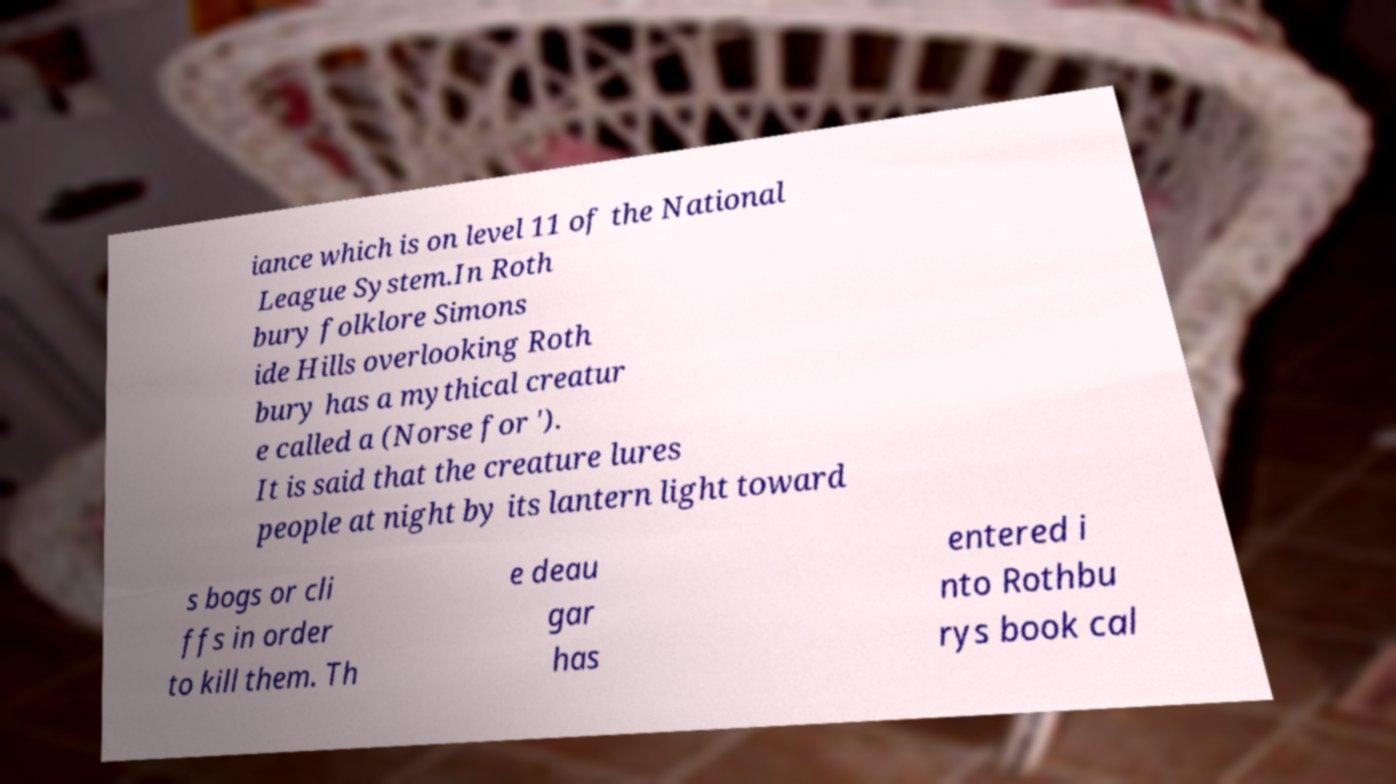What messages or text are displayed in this image? I need them in a readable, typed format. iance which is on level 11 of the National League System.In Roth bury folklore Simons ide Hills overlooking Roth bury has a mythical creatur e called a (Norse for '). It is said that the creature lures people at night by its lantern light toward s bogs or cli ffs in order to kill them. Th e deau gar has entered i nto Rothbu rys book cal 